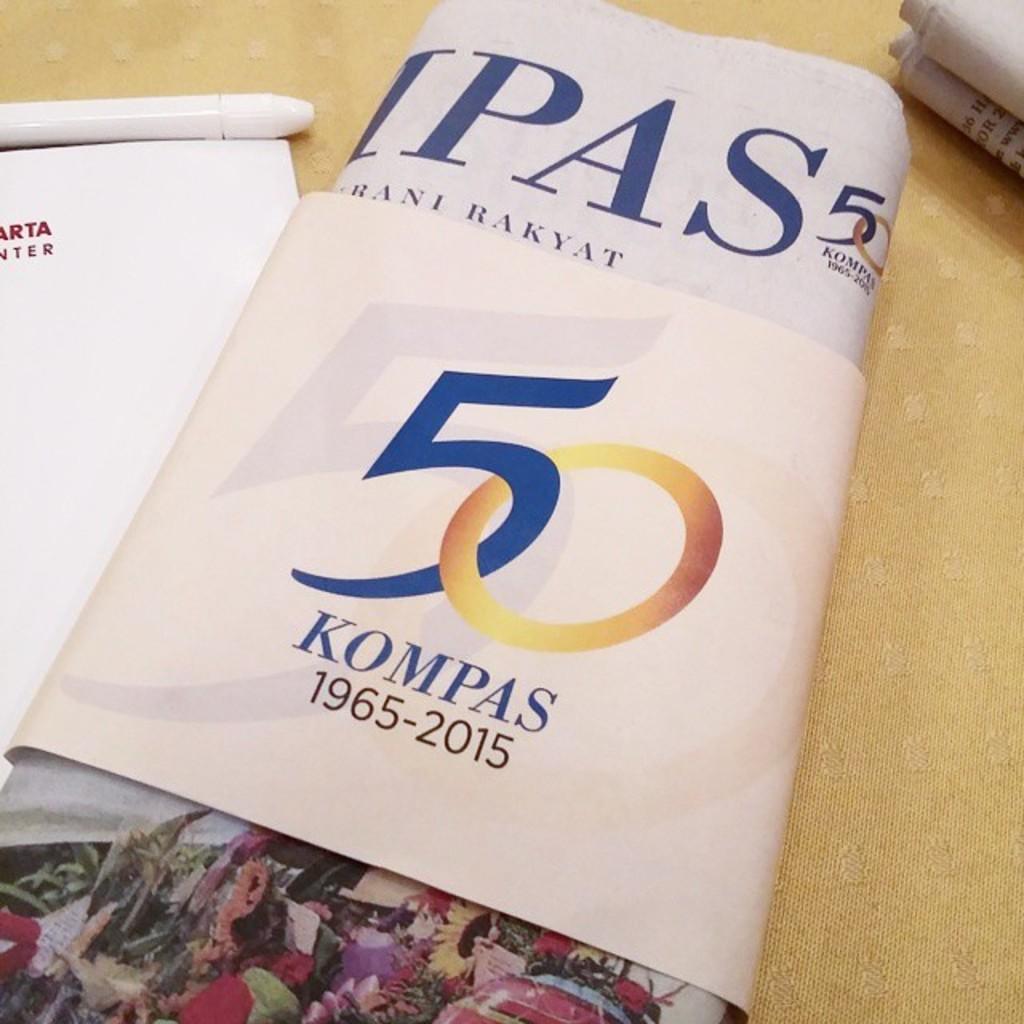What numbers are on the middle of the book?
Offer a terse response. 50. What are the dates?
Your answer should be very brief. 1965-2015. 